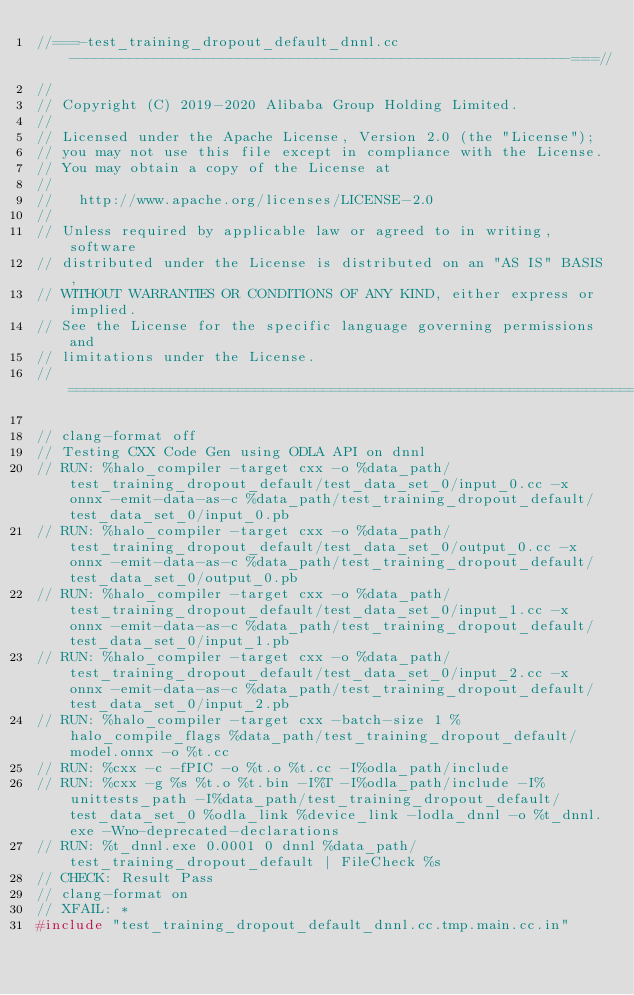Convert code to text. <code><loc_0><loc_0><loc_500><loc_500><_C++_>//===-test_training_dropout_default_dnnl.cc-----------------------------------------------------------===//
//
// Copyright (C) 2019-2020 Alibaba Group Holding Limited.
//
// Licensed under the Apache License, Version 2.0 (the "License");
// you may not use this file except in compliance with the License.
// You may obtain a copy of the License at
//
//   http://www.apache.org/licenses/LICENSE-2.0
//
// Unless required by applicable law or agreed to in writing, software
// distributed under the License is distributed on an "AS IS" BASIS,
// WITHOUT WARRANTIES OR CONDITIONS OF ANY KIND, either express or implied.
// See the License for the specific language governing permissions and
// limitations under the License.
// =============================================================================

// clang-format off
// Testing CXX Code Gen using ODLA API on dnnl
// RUN: %halo_compiler -target cxx -o %data_path/test_training_dropout_default/test_data_set_0/input_0.cc -x onnx -emit-data-as-c %data_path/test_training_dropout_default/test_data_set_0/input_0.pb
// RUN: %halo_compiler -target cxx -o %data_path/test_training_dropout_default/test_data_set_0/output_0.cc -x onnx -emit-data-as-c %data_path/test_training_dropout_default/test_data_set_0/output_0.pb
// RUN: %halo_compiler -target cxx -o %data_path/test_training_dropout_default/test_data_set_0/input_1.cc -x onnx -emit-data-as-c %data_path/test_training_dropout_default/test_data_set_0/input_1.pb
// RUN: %halo_compiler -target cxx -o %data_path/test_training_dropout_default/test_data_set_0/input_2.cc -x onnx -emit-data-as-c %data_path/test_training_dropout_default/test_data_set_0/input_2.pb
// RUN: %halo_compiler -target cxx -batch-size 1 %halo_compile_flags %data_path/test_training_dropout_default/model.onnx -o %t.cc
// RUN: %cxx -c -fPIC -o %t.o %t.cc -I%odla_path/include
// RUN: %cxx -g %s %t.o %t.bin -I%T -I%odla_path/include -I%unittests_path -I%data_path/test_training_dropout_default/test_data_set_0 %odla_link %device_link -lodla_dnnl -o %t_dnnl.exe -Wno-deprecated-declarations
// RUN: %t_dnnl.exe 0.0001 0 dnnl %data_path/test_training_dropout_default | FileCheck %s
// CHECK: Result Pass
// clang-format on
// XFAIL: *
#include "test_training_dropout_default_dnnl.cc.tmp.main.cc.in"
</code> 